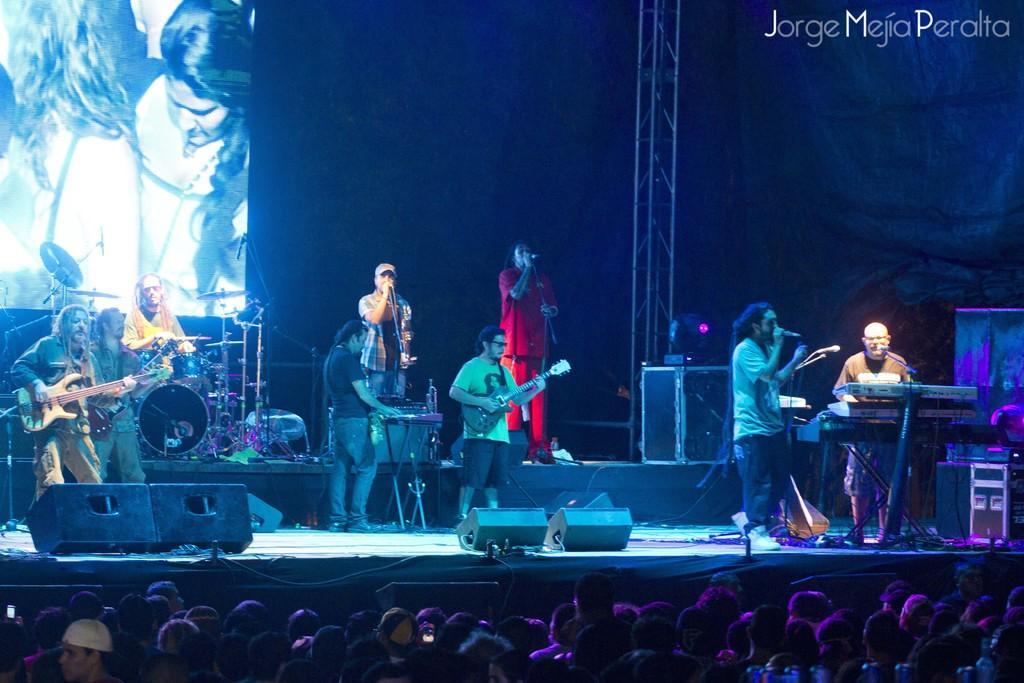Can you describe this image briefly? In this image it look like a music concert in which there are artists performing on the stage. At the bottom there are so many spectators. On the stage there are many singers who are singing with the mic while the other people are playing the guitars and drums. In the background there is a screen. On the right side there is a man who is playing the keyboard. In the middle there is a man who is playing the guitar. 